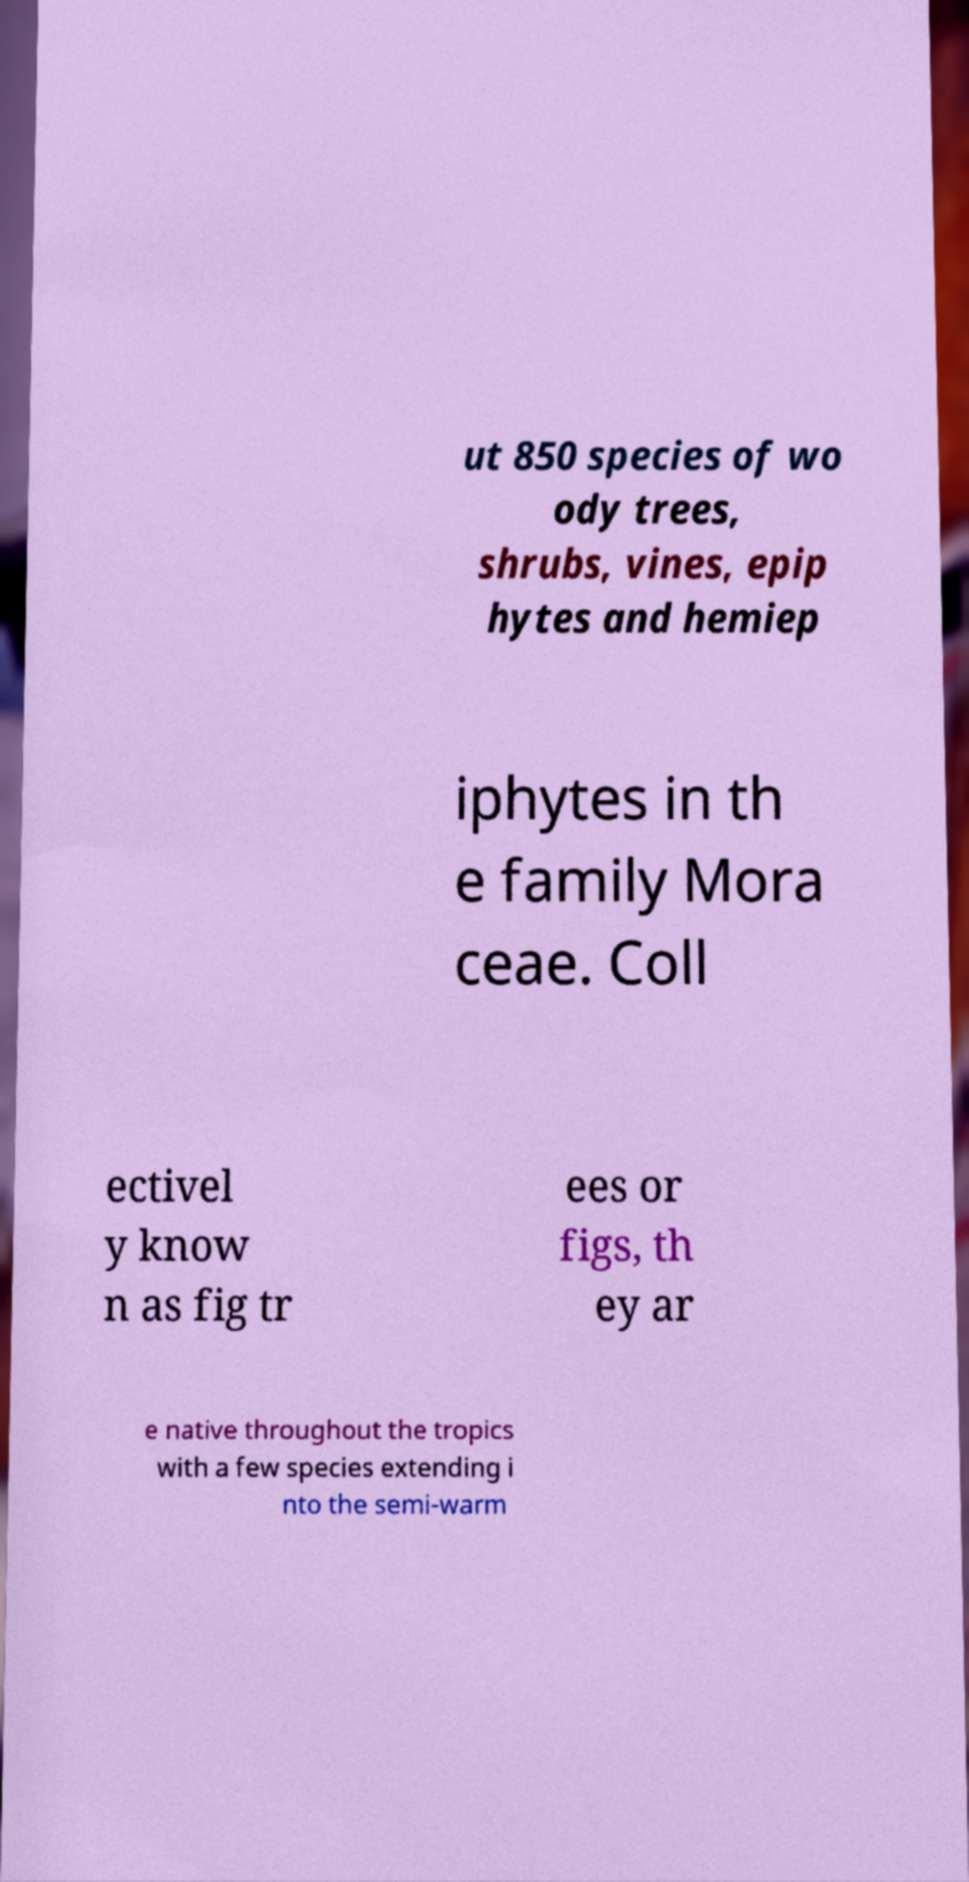I need the written content from this picture converted into text. Can you do that? ut 850 species of wo ody trees, shrubs, vines, epip hytes and hemiep iphytes in th e family Mora ceae. Coll ectivel y know n as fig tr ees or figs, th ey ar e native throughout the tropics with a few species extending i nto the semi-warm 